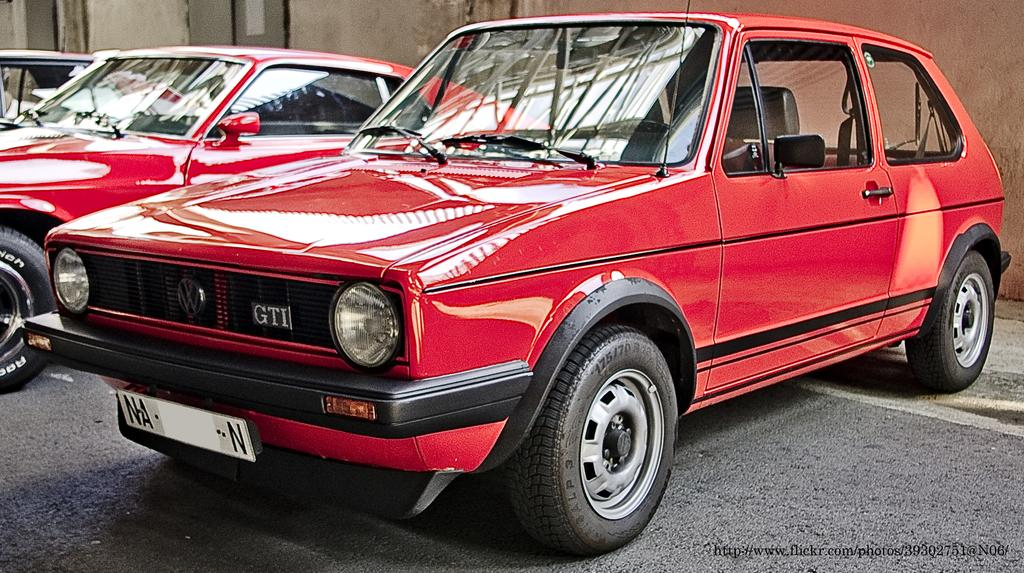<image>
Describe the image concisely. An old, red GTI automobile is parked in a parking lot next to another red, classic car, 